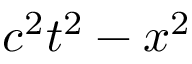<formula> <loc_0><loc_0><loc_500><loc_500>c ^ { 2 } t ^ { 2 } - x ^ { 2 }</formula> 